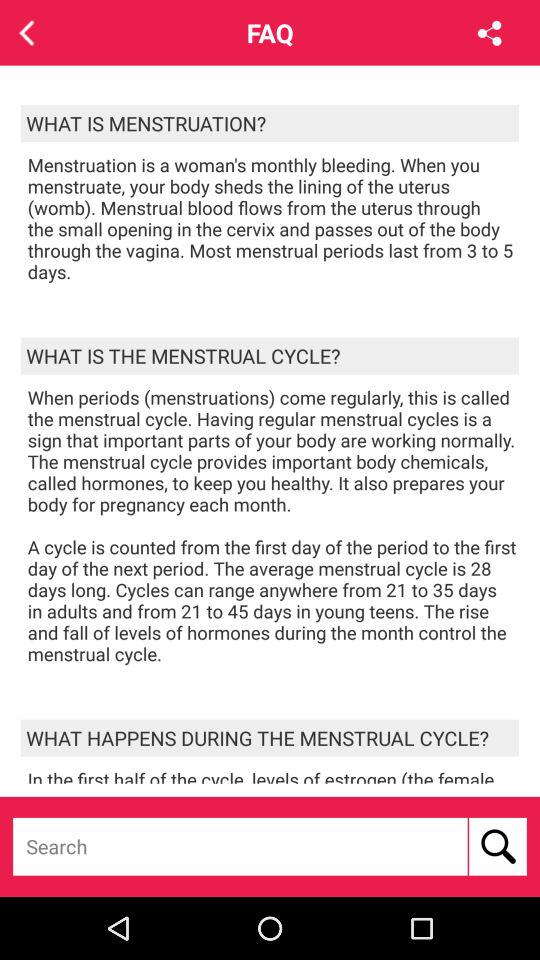What is the duration of the menstrual period? The duration is 3 to 5 days. 